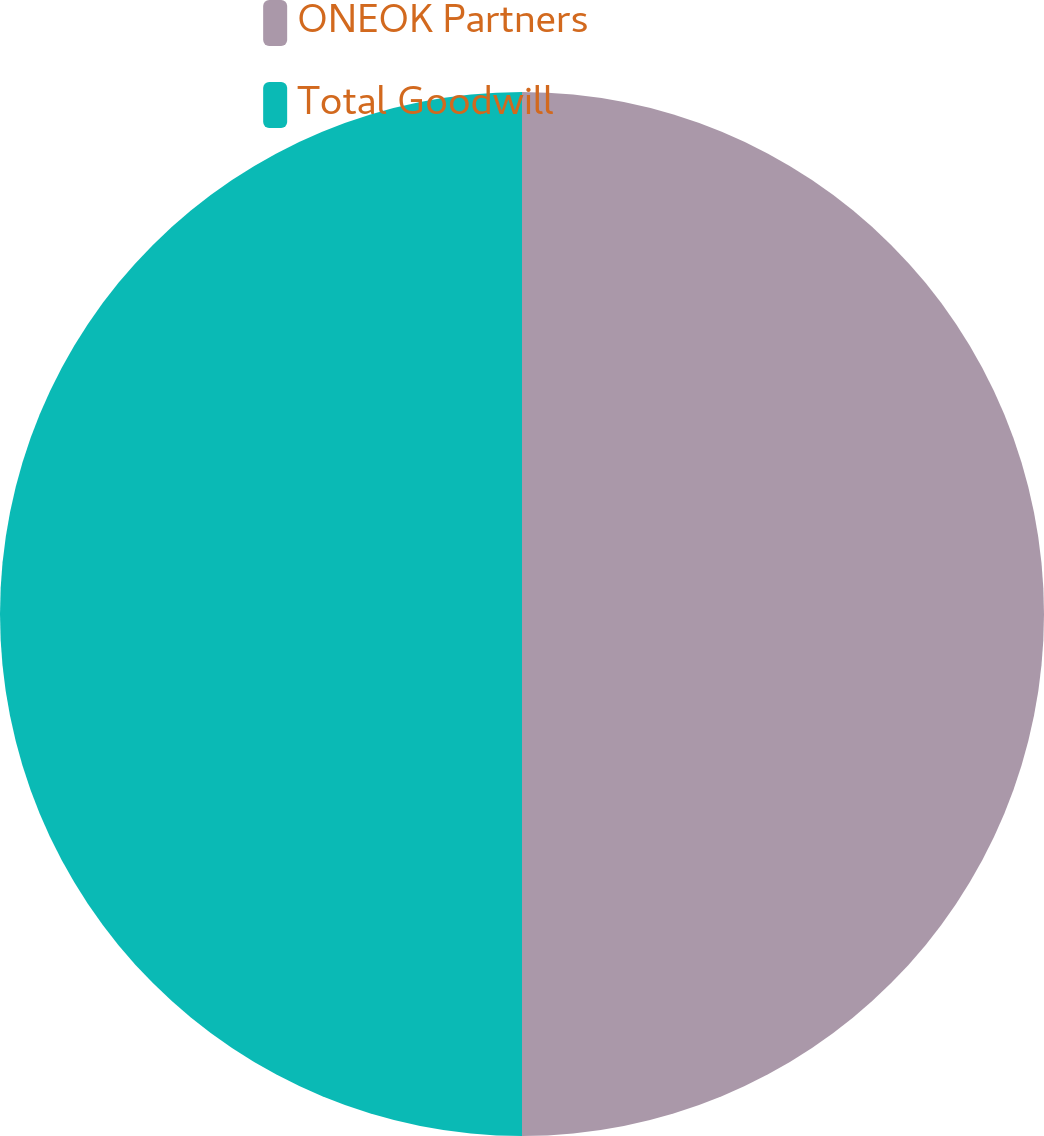Convert chart to OTSL. <chart><loc_0><loc_0><loc_500><loc_500><pie_chart><fcel>ONEOK Partners<fcel>Total Goodwill<nl><fcel>50.0%<fcel>50.0%<nl></chart> 